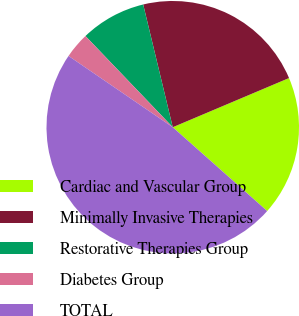<chart> <loc_0><loc_0><loc_500><loc_500><pie_chart><fcel>Cardiac and Vascular Group<fcel>Minimally Invasive Therapies<fcel>Restorative Therapies Group<fcel>Diabetes Group<fcel>TOTAL<nl><fcel>17.92%<fcel>22.39%<fcel>8.39%<fcel>3.3%<fcel>47.99%<nl></chart> 